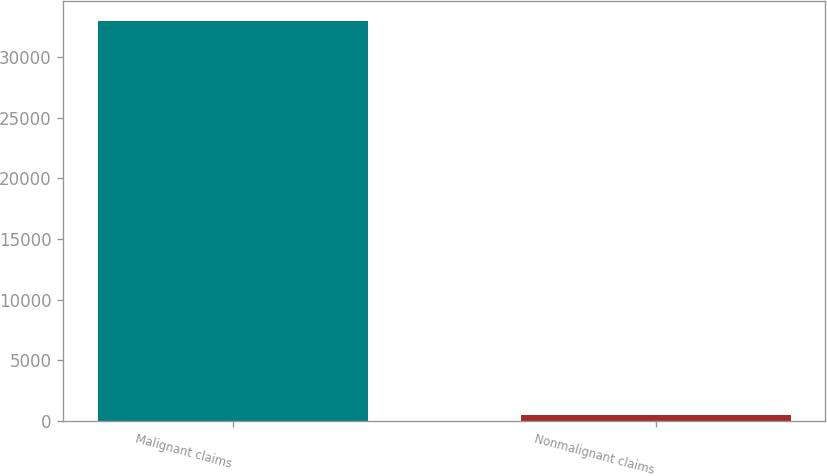Convert chart to OTSL. <chart><loc_0><loc_0><loc_500><loc_500><bar_chart><fcel>Malignant claims<fcel>Nonmalignant claims<nl><fcel>33000<fcel>500<nl></chart> 